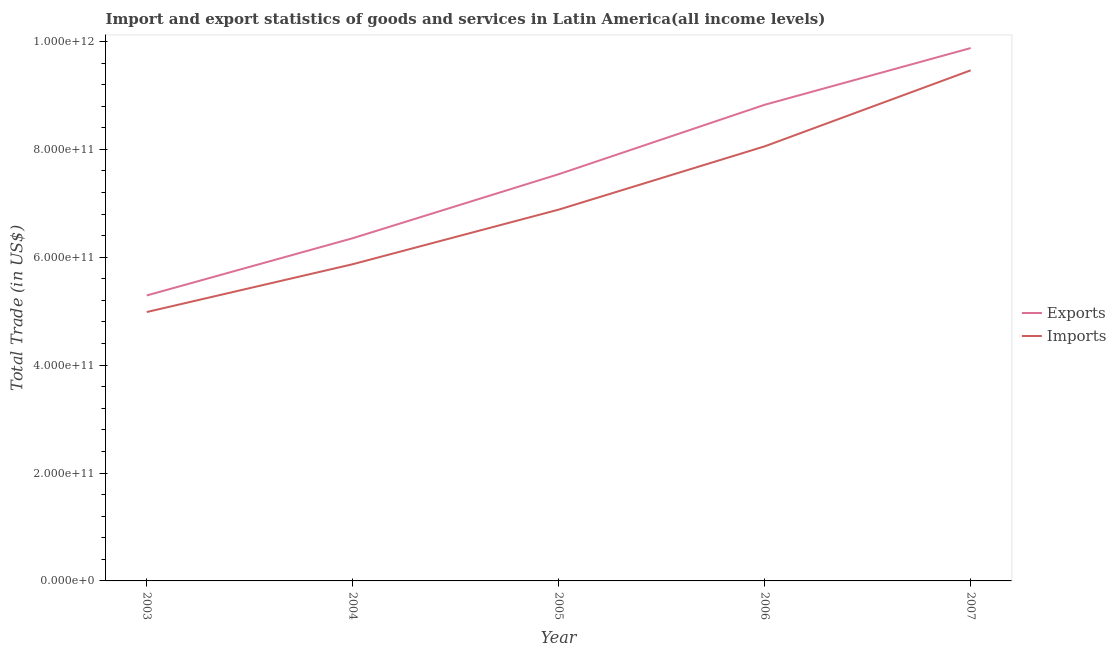How many different coloured lines are there?
Ensure brevity in your answer.  2. Is the number of lines equal to the number of legend labels?
Your response must be concise. Yes. What is the imports of goods and services in 2006?
Give a very brief answer. 8.06e+11. Across all years, what is the maximum export of goods and services?
Your response must be concise. 9.88e+11. Across all years, what is the minimum imports of goods and services?
Provide a succinct answer. 4.98e+11. In which year was the export of goods and services maximum?
Offer a terse response. 2007. What is the total imports of goods and services in the graph?
Give a very brief answer. 3.53e+12. What is the difference between the export of goods and services in 2004 and that in 2006?
Your answer should be very brief. -2.47e+11. What is the difference between the export of goods and services in 2005 and the imports of goods and services in 2007?
Your answer should be compact. -1.93e+11. What is the average export of goods and services per year?
Your answer should be very brief. 7.58e+11. In the year 2003, what is the difference between the export of goods and services and imports of goods and services?
Your answer should be very brief. 3.07e+1. In how many years, is the imports of goods and services greater than 440000000000 US$?
Offer a very short reply. 5. What is the ratio of the imports of goods and services in 2004 to that in 2007?
Offer a terse response. 0.62. Is the imports of goods and services in 2004 less than that in 2005?
Keep it short and to the point. Yes. What is the difference between the highest and the second highest export of goods and services?
Provide a short and direct response. 1.05e+11. What is the difference between the highest and the lowest imports of goods and services?
Your answer should be very brief. 4.48e+11. In how many years, is the imports of goods and services greater than the average imports of goods and services taken over all years?
Keep it short and to the point. 2. Is the sum of the export of goods and services in 2006 and 2007 greater than the maximum imports of goods and services across all years?
Your answer should be compact. Yes. Does the export of goods and services monotonically increase over the years?
Give a very brief answer. Yes. Is the export of goods and services strictly greater than the imports of goods and services over the years?
Offer a very short reply. Yes. Is the imports of goods and services strictly less than the export of goods and services over the years?
Offer a very short reply. Yes. How many years are there in the graph?
Your response must be concise. 5. What is the difference between two consecutive major ticks on the Y-axis?
Provide a succinct answer. 2.00e+11. Are the values on the major ticks of Y-axis written in scientific E-notation?
Provide a succinct answer. Yes. Does the graph contain any zero values?
Ensure brevity in your answer.  No. Where does the legend appear in the graph?
Ensure brevity in your answer.  Center right. What is the title of the graph?
Your answer should be very brief. Import and export statistics of goods and services in Latin America(all income levels). What is the label or title of the X-axis?
Your response must be concise. Year. What is the label or title of the Y-axis?
Your response must be concise. Total Trade (in US$). What is the Total Trade (in US$) in Exports in 2003?
Give a very brief answer. 5.29e+11. What is the Total Trade (in US$) of Imports in 2003?
Give a very brief answer. 4.98e+11. What is the Total Trade (in US$) of Exports in 2004?
Offer a very short reply. 6.35e+11. What is the Total Trade (in US$) in Imports in 2004?
Provide a short and direct response. 5.87e+11. What is the Total Trade (in US$) of Exports in 2005?
Ensure brevity in your answer.  7.54e+11. What is the Total Trade (in US$) in Imports in 2005?
Your answer should be compact. 6.88e+11. What is the Total Trade (in US$) of Exports in 2006?
Your response must be concise. 8.83e+11. What is the Total Trade (in US$) of Imports in 2006?
Offer a very short reply. 8.06e+11. What is the Total Trade (in US$) in Exports in 2007?
Make the answer very short. 9.88e+11. What is the Total Trade (in US$) in Imports in 2007?
Your response must be concise. 9.46e+11. Across all years, what is the maximum Total Trade (in US$) of Exports?
Offer a terse response. 9.88e+11. Across all years, what is the maximum Total Trade (in US$) of Imports?
Make the answer very short. 9.46e+11. Across all years, what is the minimum Total Trade (in US$) of Exports?
Keep it short and to the point. 5.29e+11. Across all years, what is the minimum Total Trade (in US$) in Imports?
Your answer should be compact. 4.98e+11. What is the total Total Trade (in US$) of Exports in the graph?
Your answer should be compact. 3.79e+12. What is the total Total Trade (in US$) of Imports in the graph?
Provide a short and direct response. 3.53e+12. What is the difference between the Total Trade (in US$) in Exports in 2003 and that in 2004?
Offer a terse response. -1.06e+11. What is the difference between the Total Trade (in US$) of Imports in 2003 and that in 2004?
Offer a terse response. -8.86e+1. What is the difference between the Total Trade (in US$) of Exports in 2003 and that in 2005?
Your answer should be compact. -2.25e+11. What is the difference between the Total Trade (in US$) of Imports in 2003 and that in 2005?
Provide a short and direct response. -1.90e+11. What is the difference between the Total Trade (in US$) in Exports in 2003 and that in 2006?
Keep it short and to the point. -3.53e+11. What is the difference between the Total Trade (in US$) of Imports in 2003 and that in 2006?
Your response must be concise. -3.07e+11. What is the difference between the Total Trade (in US$) of Exports in 2003 and that in 2007?
Make the answer very short. -4.59e+11. What is the difference between the Total Trade (in US$) in Imports in 2003 and that in 2007?
Provide a short and direct response. -4.48e+11. What is the difference between the Total Trade (in US$) in Exports in 2004 and that in 2005?
Provide a short and direct response. -1.19e+11. What is the difference between the Total Trade (in US$) of Imports in 2004 and that in 2005?
Your response must be concise. -1.01e+11. What is the difference between the Total Trade (in US$) of Exports in 2004 and that in 2006?
Make the answer very short. -2.47e+11. What is the difference between the Total Trade (in US$) in Imports in 2004 and that in 2006?
Provide a succinct answer. -2.18e+11. What is the difference between the Total Trade (in US$) of Exports in 2004 and that in 2007?
Offer a very short reply. -3.52e+11. What is the difference between the Total Trade (in US$) in Imports in 2004 and that in 2007?
Give a very brief answer. -3.59e+11. What is the difference between the Total Trade (in US$) in Exports in 2005 and that in 2006?
Your response must be concise. -1.29e+11. What is the difference between the Total Trade (in US$) of Imports in 2005 and that in 2006?
Provide a succinct answer. -1.17e+11. What is the difference between the Total Trade (in US$) of Exports in 2005 and that in 2007?
Offer a terse response. -2.34e+11. What is the difference between the Total Trade (in US$) in Imports in 2005 and that in 2007?
Offer a very short reply. -2.58e+11. What is the difference between the Total Trade (in US$) of Exports in 2006 and that in 2007?
Your response must be concise. -1.05e+11. What is the difference between the Total Trade (in US$) of Imports in 2006 and that in 2007?
Keep it short and to the point. -1.41e+11. What is the difference between the Total Trade (in US$) in Exports in 2003 and the Total Trade (in US$) in Imports in 2004?
Give a very brief answer. -5.79e+1. What is the difference between the Total Trade (in US$) of Exports in 2003 and the Total Trade (in US$) of Imports in 2005?
Your answer should be very brief. -1.59e+11. What is the difference between the Total Trade (in US$) in Exports in 2003 and the Total Trade (in US$) in Imports in 2006?
Your response must be concise. -2.76e+11. What is the difference between the Total Trade (in US$) in Exports in 2003 and the Total Trade (in US$) in Imports in 2007?
Keep it short and to the point. -4.17e+11. What is the difference between the Total Trade (in US$) of Exports in 2004 and the Total Trade (in US$) of Imports in 2005?
Make the answer very short. -5.30e+1. What is the difference between the Total Trade (in US$) in Exports in 2004 and the Total Trade (in US$) in Imports in 2006?
Ensure brevity in your answer.  -1.70e+11. What is the difference between the Total Trade (in US$) in Exports in 2004 and the Total Trade (in US$) in Imports in 2007?
Offer a very short reply. -3.11e+11. What is the difference between the Total Trade (in US$) of Exports in 2005 and the Total Trade (in US$) of Imports in 2006?
Give a very brief answer. -5.16e+1. What is the difference between the Total Trade (in US$) of Exports in 2005 and the Total Trade (in US$) of Imports in 2007?
Make the answer very short. -1.93e+11. What is the difference between the Total Trade (in US$) of Exports in 2006 and the Total Trade (in US$) of Imports in 2007?
Give a very brief answer. -6.38e+1. What is the average Total Trade (in US$) of Exports per year?
Make the answer very short. 7.58e+11. What is the average Total Trade (in US$) of Imports per year?
Ensure brevity in your answer.  7.05e+11. In the year 2003, what is the difference between the Total Trade (in US$) of Exports and Total Trade (in US$) of Imports?
Keep it short and to the point. 3.07e+1. In the year 2004, what is the difference between the Total Trade (in US$) in Exports and Total Trade (in US$) in Imports?
Your response must be concise. 4.82e+1. In the year 2005, what is the difference between the Total Trade (in US$) of Exports and Total Trade (in US$) of Imports?
Offer a terse response. 6.57e+1. In the year 2006, what is the difference between the Total Trade (in US$) in Exports and Total Trade (in US$) in Imports?
Your answer should be very brief. 7.71e+1. In the year 2007, what is the difference between the Total Trade (in US$) in Exports and Total Trade (in US$) in Imports?
Offer a very short reply. 4.12e+1. What is the ratio of the Total Trade (in US$) of Exports in 2003 to that in 2004?
Your answer should be compact. 0.83. What is the ratio of the Total Trade (in US$) in Imports in 2003 to that in 2004?
Make the answer very short. 0.85. What is the ratio of the Total Trade (in US$) of Exports in 2003 to that in 2005?
Your answer should be compact. 0.7. What is the ratio of the Total Trade (in US$) in Imports in 2003 to that in 2005?
Your response must be concise. 0.72. What is the ratio of the Total Trade (in US$) of Exports in 2003 to that in 2006?
Give a very brief answer. 0.6. What is the ratio of the Total Trade (in US$) of Imports in 2003 to that in 2006?
Your answer should be compact. 0.62. What is the ratio of the Total Trade (in US$) in Exports in 2003 to that in 2007?
Keep it short and to the point. 0.54. What is the ratio of the Total Trade (in US$) in Imports in 2003 to that in 2007?
Your response must be concise. 0.53. What is the ratio of the Total Trade (in US$) in Exports in 2004 to that in 2005?
Ensure brevity in your answer.  0.84. What is the ratio of the Total Trade (in US$) in Imports in 2004 to that in 2005?
Provide a short and direct response. 0.85. What is the ratio of the Total Trade (in US$) of Exports in 2004 to that in 2006?
Your response must be concise. 0.72. What is the ratio of the Total Trade (in US$) in Imports in 2004 to that in 2006?
Ensure brevity in your answer.  0.73. What is the ratio of the Total Trade (in US$) in Exports in 2004 to that in 2007?
Provide a short and direct response. 0.64. What is the ratio of the Total Trade (in US$) of Imports in 2004 to that in 2007?
Your answer should be compact. 0.62. What is the ratio of the Total Trade (in US$) of Exports in 2005 to that in 2006?
Your answer should be compact. 0.85. What is the ratio of the Total Trade (in US$) of Imports in 2005 to that in 2006?
Ensure brevity in your answer.  0.85. What is the ratio of the Total Trade (in US$) of Exports in 2005 to that in 2007?
Offer a very short reply. 0.76. What is the ratio of the Total Trade (in US$) of Imports in 2005 to that in 2007?
Provide a succinct answer. 0.73. What is the ratio of the Total Trade (in US$) in Exports in 2006 to that in 2007?
Offer a very short reply. 0.89. What is the ratio of the Total Trade (in US$) in Imports in 2006 to that in 2007?
Your answer should be very brief. 0.85. What is the difference between the highest and the second highest Total Trade (in US$) of Exports?
Keep it short and to the point. 1.05e+11. What is the difference between the highest and the second highest Total Trade (in US$) in Imports?
Provide a succinct answer. 1.41e+11. What is the difference between the highest and the lowest Total Trade (in US$) of Exports?
Offer a very short reply. 4.59e+11. What is the difference between the highest and the lowest Total Trade (in US$) in Imports?
Offer a very short reply. 4.48e+11. 